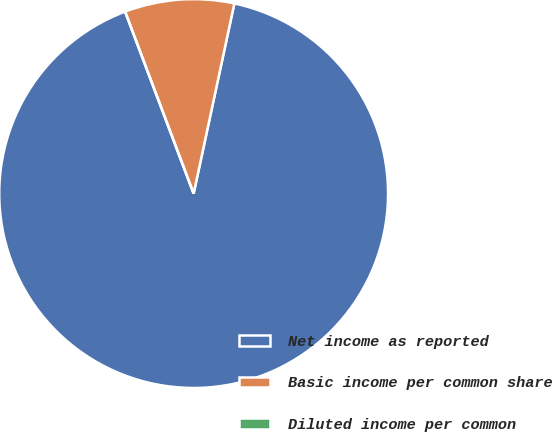<chart> <loc_0><loc_0><loc_500><loc_500><pie_chart><fcel>Net income as reported<fcel>Basic income per common share<fcel>Diluted income per common<nl><fcel>90.91%<fcel>9.09%<fcel>0.0%<nl></chart> 